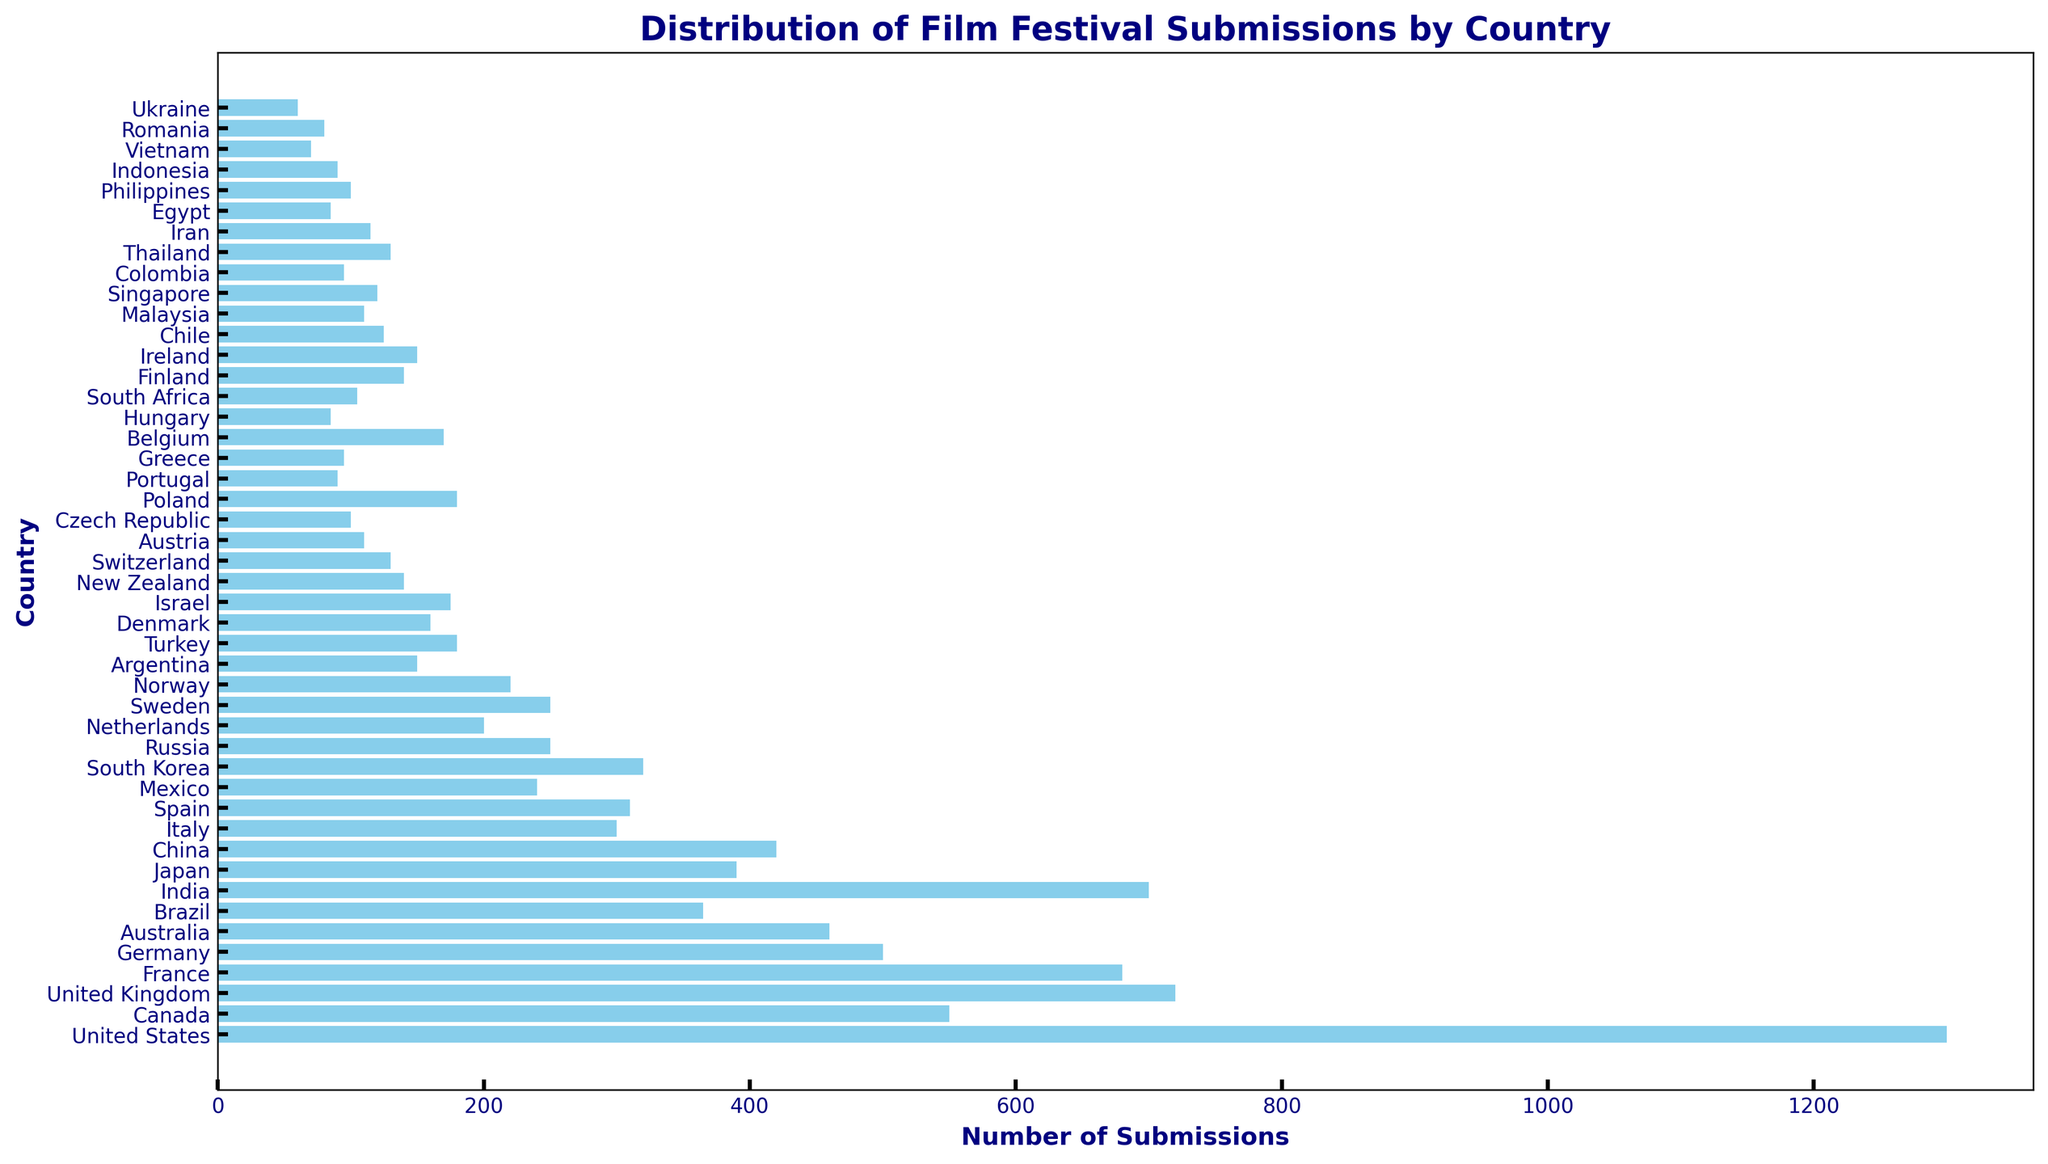How many submissions were made by the United States compared to Canada? The bar for the United States is taller than that for Canada. The figure shows 1300 submissions for the United States and 550 for Canada. Therefore, the submissions from the United States are 1300 - 550 = 750 more than those from Canada.
Answer: 750 What is the total number of submissions from France and Germany? The figures for France and Germany are 680 and 500, respectively. Adding these gives 680 + 500 = 1180.
Answer: 1180 Which country has more submissions: India or Japan? The bar for India is taller than the bar for Japan. The figure shows 700 submissions for India and 390 for Japan. Therefore, India has more submissions.
Answer: India Are there any countries with the same number of submissions? The figure shows both Russia and Sweden have 250 submissions according to the height of their bars. Therefore, these two countries share the same number of submissions.
Answer: Russia and Sweden What is the average number of submissions across the top five countries? The top five countries in terms of submissions are the United States (1300), Canada (550), United Kingdom (720), France (680), and India (700). Adding these values gives 1300 + 550 + 720 + 680 + 700 = 3950. Dividing by 5, the average is 3950 / 5 = 790.
Answer: 790 What is the difference in submissions between the country with the most submissions and the country with the least submissions? The country with the most submissions is the United States with 1300 submissions, and the country with the least is Ukraine with 60 submissions. The difference is 1300 - 60 = 1240.
Answer: 1240 